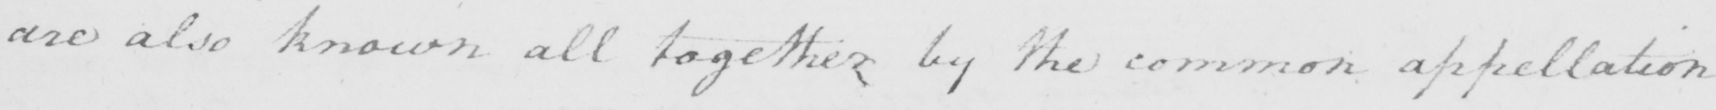Can you tell me what this handwritten text says? are also known all together by the common appellation 